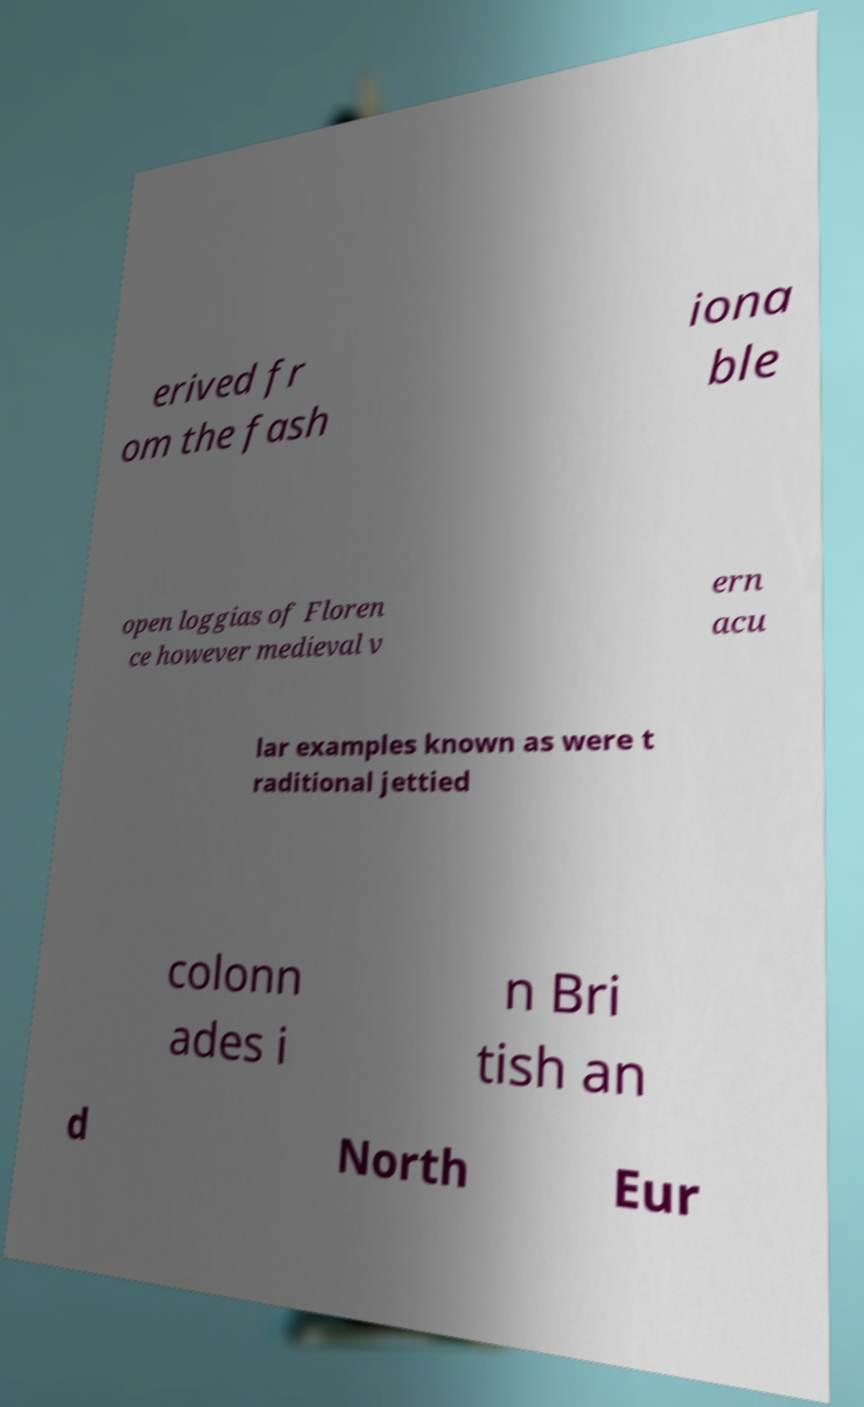Please identify and transcribe the text found in this image. erived fr om the fash iona ble open loggias of Floren ce however medieval v ern acu lar examples known as were t raditional jettied colonn ades i n Bri tish an d North Eur 